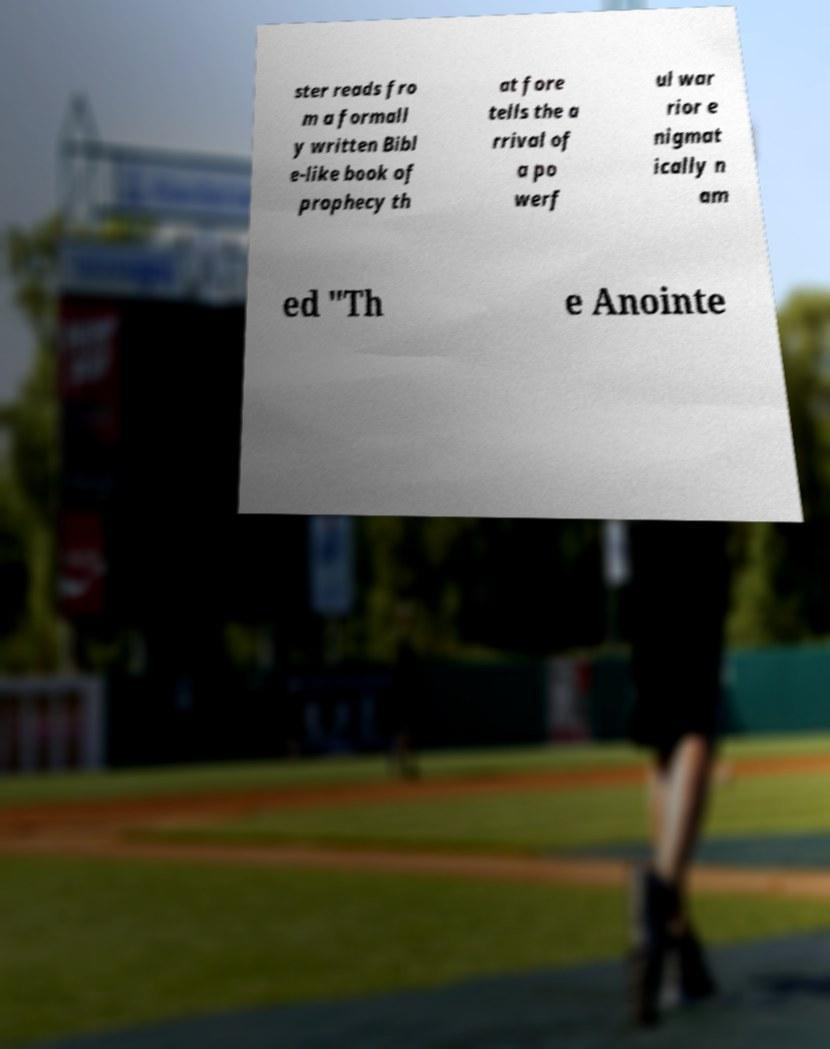There's text embedded in this image that I need extracted. Can you transcribe it verbatim? ster reads fro m a formall y written Bibl e-like book of prophecy th at fore tells the a rrival of a po werf ul war rior e nigmat ically n am ed "Th e Anointe 